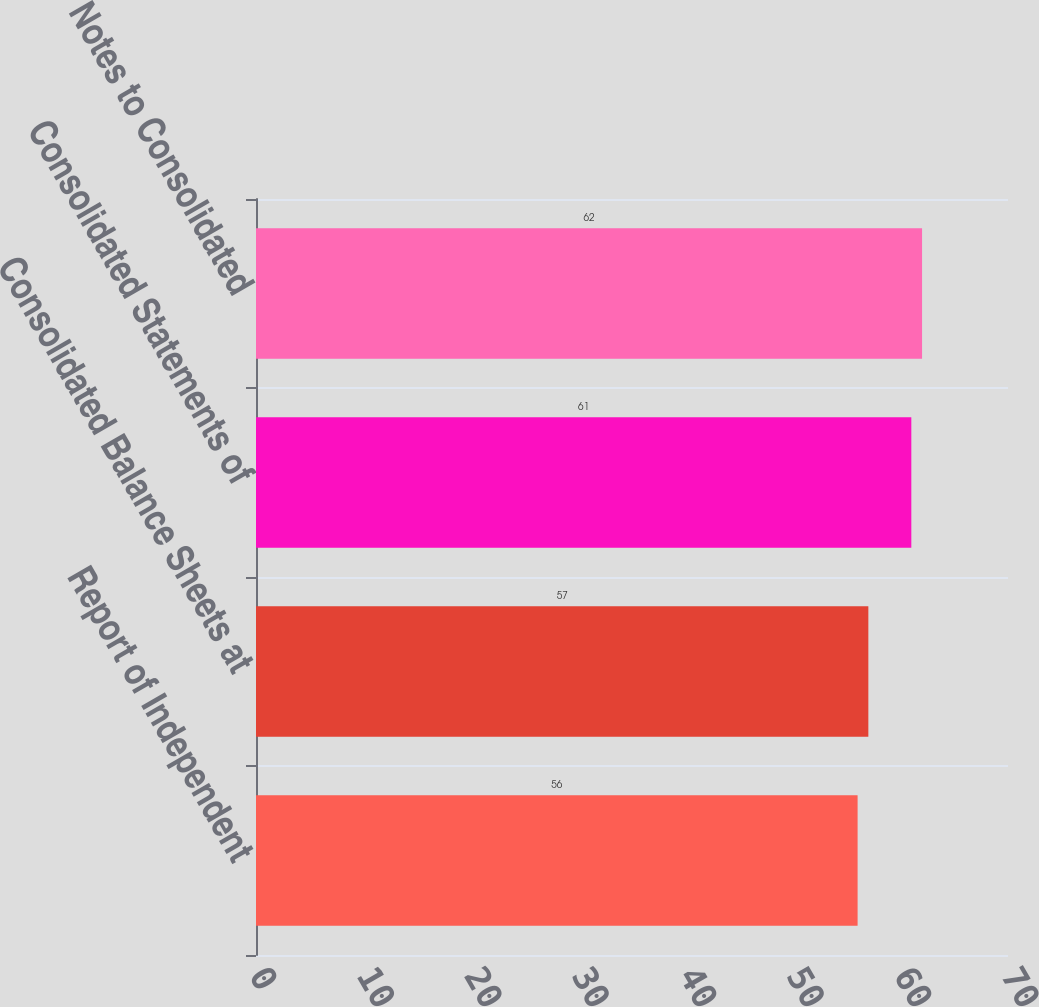Convert chart. <chart><loc_0><loc_0><loc_500><loc_500><bar_chart><fcel>Report of Independent<fcel>Consolidated Balance Sheets at<fcel>Consolidated Statements of<fcel>Notes to Consolidated<nl><fcel>56<fcel>57<fcel>61<fcel>62<nl></chart> 